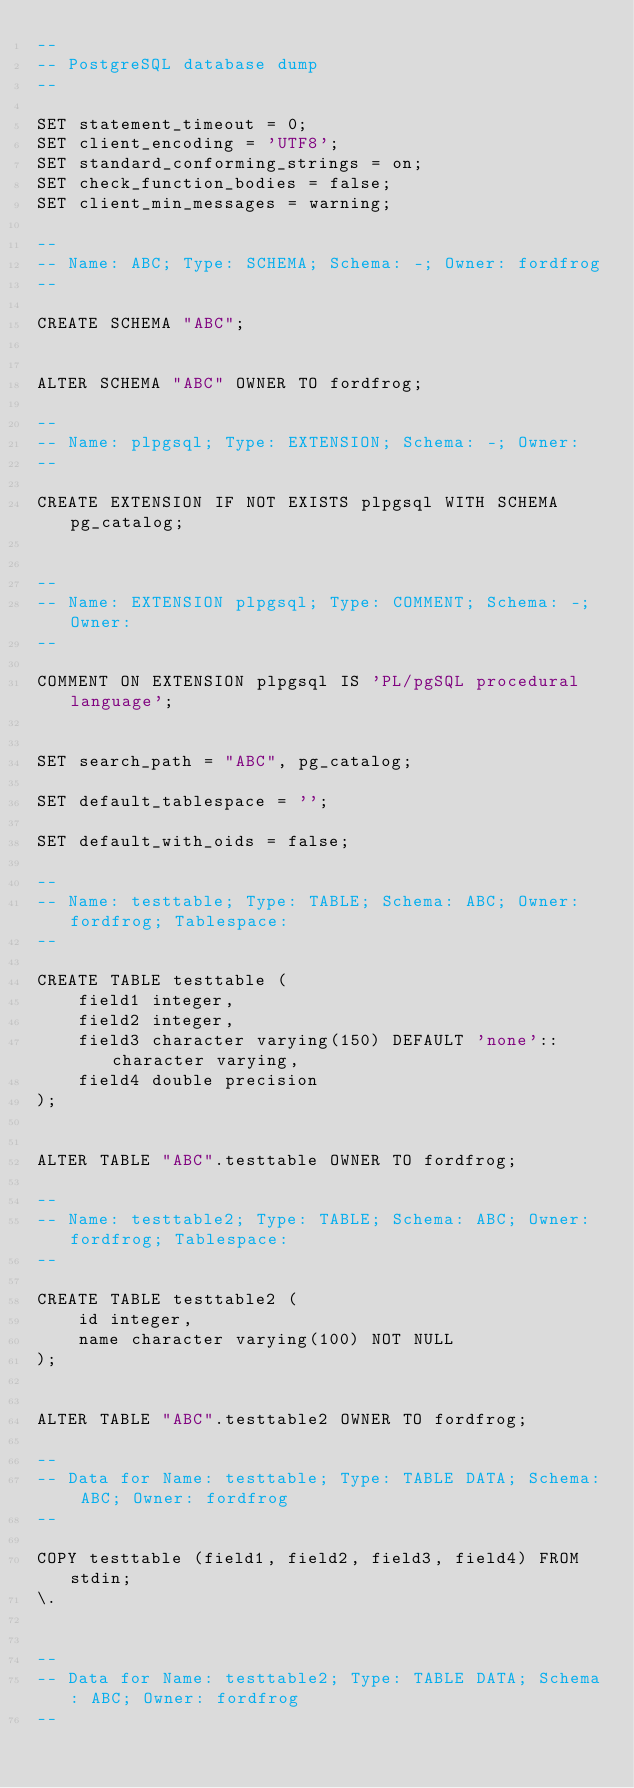Convert code to text. <code><loc_0><loc_0><loc_500><loc_500><_SQL_>--
-- PostgreSQL database dump
--

SET statement_timeout = 0;
SET client_encoding = 'UTF8';
SET standard_conforming_strings = on;
SET check_function_bodies = false;
SET client_min_messages = warning;

--
-- Name: ABC; Type: SCHEMA; Schema: -; Owner: fordfrog
--

CREATE SCHEMA "ABC";


ALTER SCHEMA "ABC" OWNER TO fordfrog;

--
-- Name: plpgsql; Type: EXTENSION; Schema: -; Owner: 
--

CREATE EXTENSION IF NOT EXISTS plpgsql WITH SCHEMA pg_catalog;


--
-- Name: EXTENSION plpgsql; Type: COMMENT; Schema: -; Owner: 
--

COMMENT ON EXTENSION plpgsql IS 'PL/pgSQL procedural language';


SET search_path = "ABC", pg_catalog;

SET default_tablespace = '';

SET default_with_oids = false;

--
-- Name: testtable; Type: TABLE; Schema: ABC; Owner: fordfrog; Tablespace: 
--

CREATE TABLE testtable (
    field1 integer,
    field2 integer,
    field3 character varying(150) DEFAULT 'none'::character varying,
    field4 double precision
);


ALTER TABLE "ABC".testtable OWNER TO fordfrog;

--
-- Name: testtable2; Type: TABLE; Schema: ABC; Owner: fordfrog; Tablespace: 
--

CREATE TABLE testtable2 (
    id integer,
    name character varying(100) NOT NULL
);


ALTER TABLE "ABC".testtable2 OWNER TO fordfrog;

--
-- Data for Name: testtable; Type: TABLE DATA; Schema: ABC; Owner: fordfrog
--

COPY testtable (field1, field2, field3, field4) FROM stdin;
\.


--
-- Data for Name: testtable2; Type: TABLE DATA; Schema: ABC; Owner: fordfrog
--
</code> 